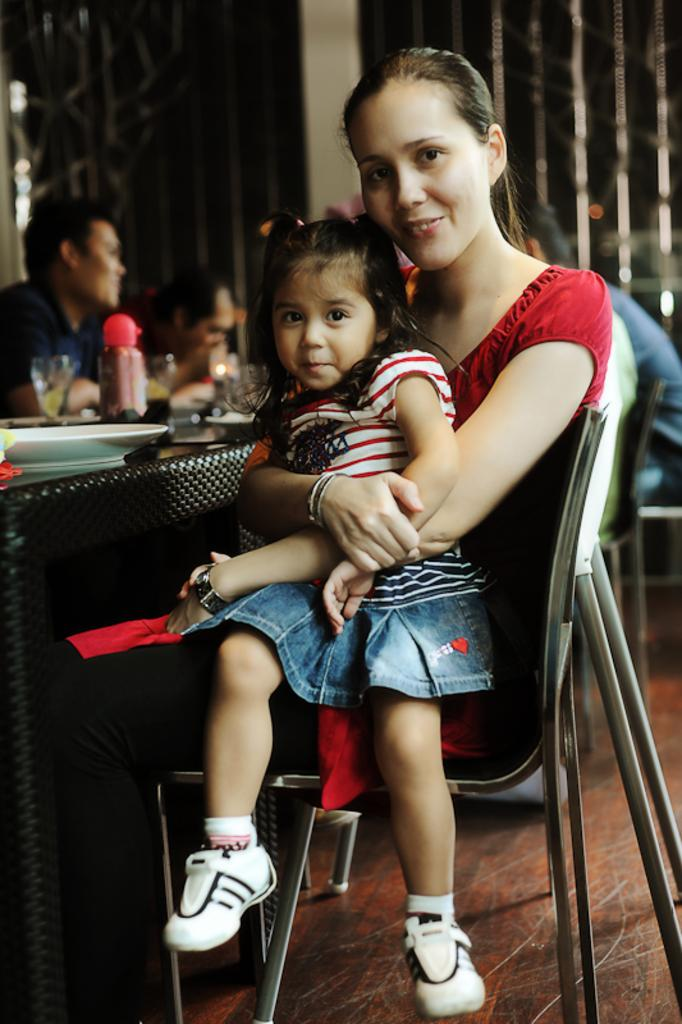What is the woman in the image doing? The woman is sitting in the image and holding a baby. Where is the woman sitting with the baby? The woman and baby are sitting on a chair. How many men are sitting in the image? There are multiple men sitting in the image. What type of songs can be heard being sung by the lettuce in the image? There is no lettuce present in the image, and therefore no songs can be heard being sung by it. 